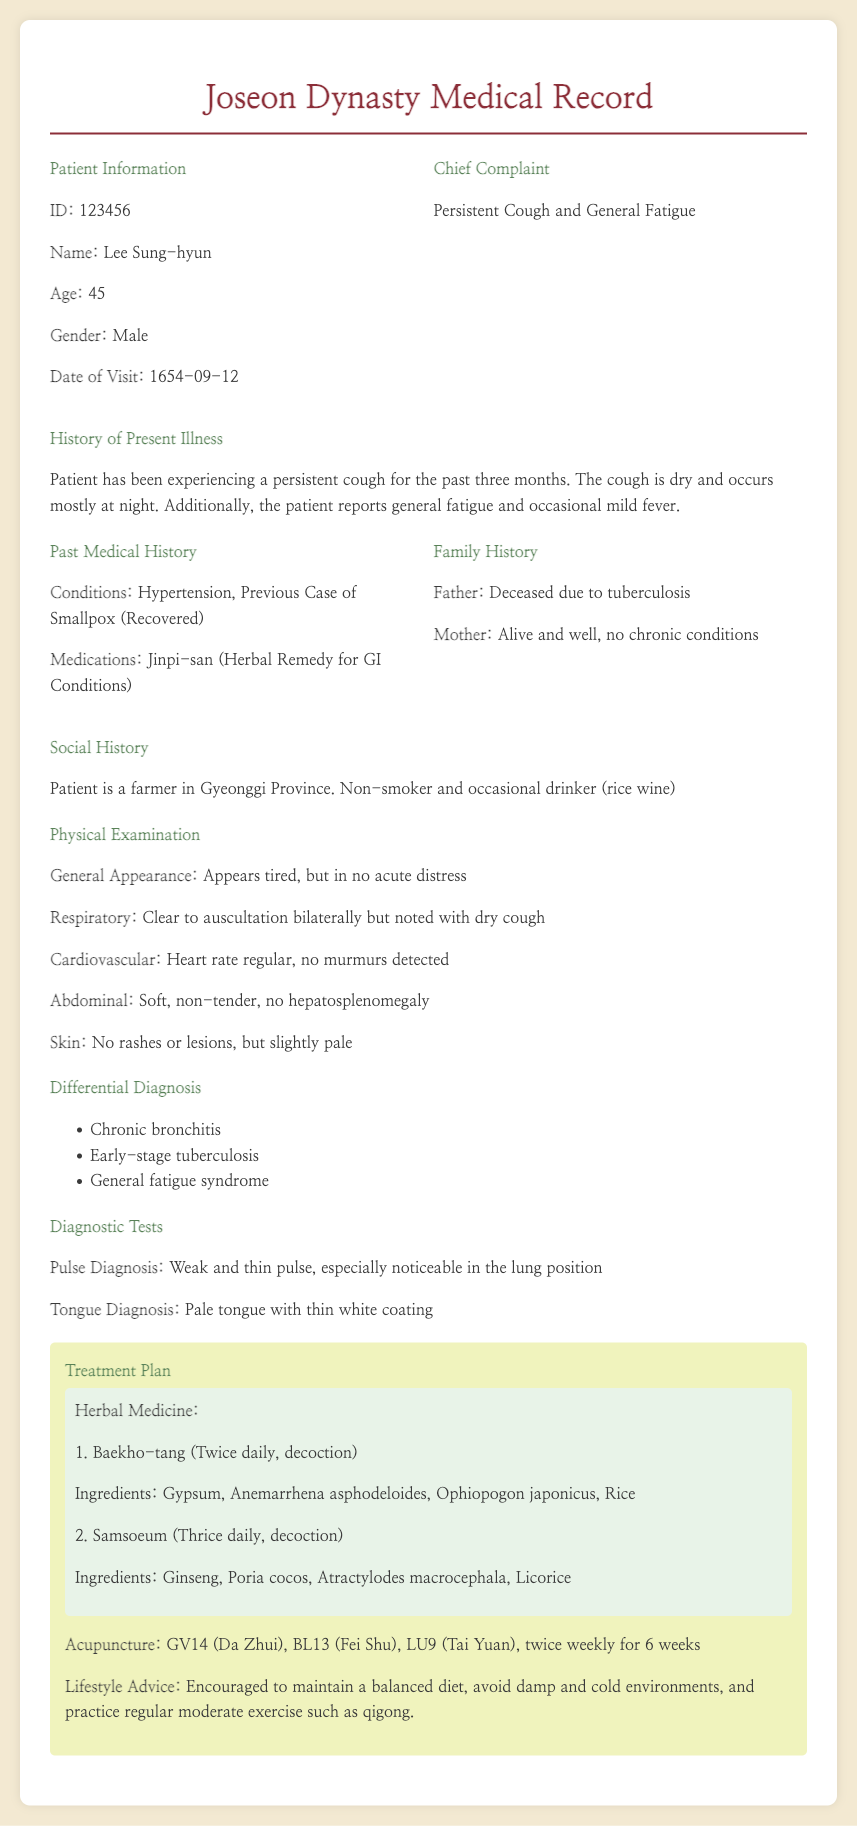What is the patient's name? The name of the patient is provided in the document under Patient Information.
Answer: Lee Sung-hyun What is the date of the patient's visit? The date of the visit is mentioned explicitly in the Patient Information section.
Answer: 1654-09-12 What are the chief complaints of the patient? The chief complaints are listed right after the patient's information in the document.
Answer: Persistent Cough and General Fatigue What herbal medicine is prescribed for the patient? The names of the herbal medicines are detailed in the Treatment Plan section of the document.
Answer: Baekho-tang and Samsoeum What does the pulse diagnosis describe? The pulse diagnosis information is given in the Diagnostic Tests section, detailing the patient's condition.
Answer: Weak and thin pulse, especially noticeable in the lung position What is one of the past medical conditions of the patient? The past medical history mentions conditions that the patient has had.
Answer: Hypertension How many times per week is acupuncture scheduled? The frequency of acupuncture sessions is mentioned in the Treatment Plan section of the document.
Answer: Twice weekly What lifestyle advice was given to the patient? Lifestyle advice is part of the Treatment Plan, summarizing recommendations for the patient's well-being.
Answer: Maintain a balanced diet, avoid damp and cold environments, and practice regular moderate exercise such as qigong What was the patient's general appearance during the physical examination? The overall description of the patient's condition can be found in the Physical Examination section.
Answer: Appears tired, but in no acute distress 